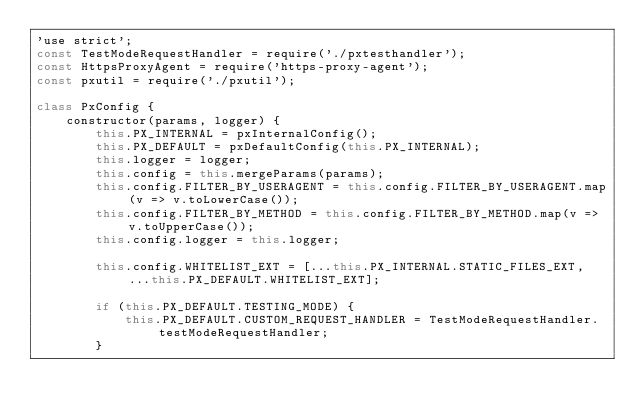Convert code to text. <code><loc_0><loc_0><loc_500><loc_500><_JavaScript_>'use strict';
const TestModeRequestHandler = require('./pxtesthandler');
const HttpsProxyAgent = require('https-proxy-agent');
const pxutil = require('./pxutil');

class PxConfig {
    constructor(params, logger) {
        this.PX_INTERNAL = pxInternalConfig();
        this.PX_DEFAULT = pxDefaultConfig(this.PX_INTERNAL);
        this.logger = logger;
        this.config = this.mergeParams(params);
        this.config.FILTER_BY_USERAGENT = this.config.FILTER_BY_USERAGENT.map(v => v.toLowerCase());
        this.config.FILTER_BY_METHOD = this.config.FILTER_BY_METHOD.map(v => v.toUpperCase());
        this.config.logger = this.logger;

        this.config.WHITELIST_EXT = [...this.PX_INTERNAL.STATIC_FILES_EXT, ...this.PX_DEFAULT.WHITELIST_EXT];

        if (this.PX_DEFAULT.TESTING_MODE) {
            this.PX_DEFAULT.CUSTOM_REQUEST_HANDLER = TestModeRequestHandler.testModeRequestHandler;
        }
</code> 